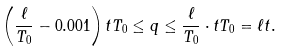<formula> <loc_0><loc_0><loc_500><loc_500>\left ( \frac { \ell } { T _ { 0 } } - 0 . 0 0 1 \right ) t T _ { 0 } \leq q \leq \frac { \ell } { T _ { 0 } } \cdot t T _ { 0 } = \ell t .</formula> 